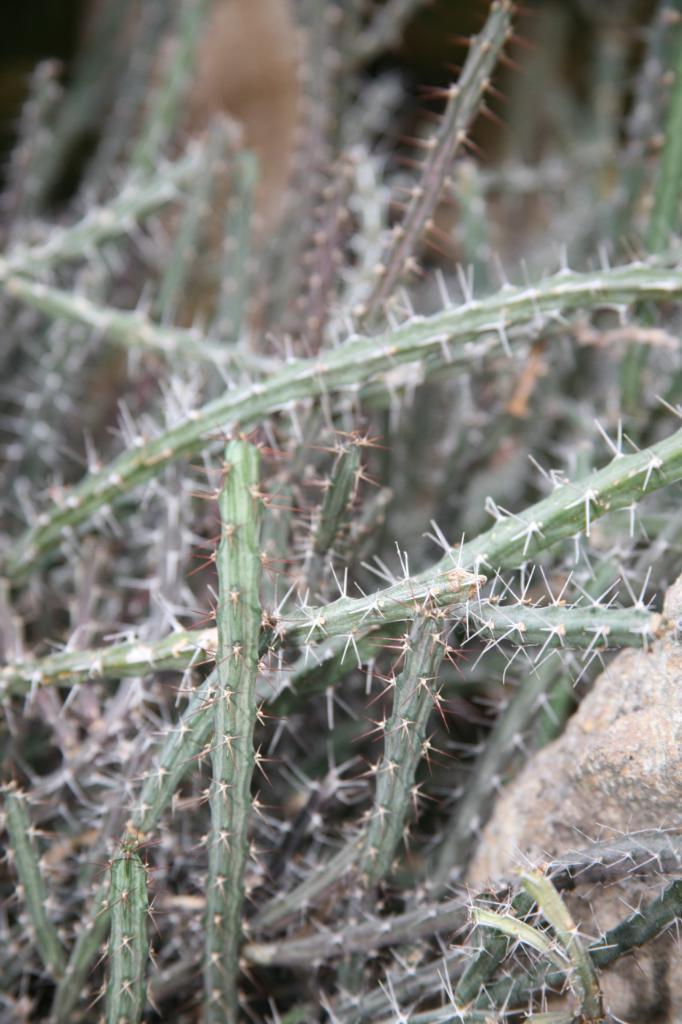How would you summarize this image in a sentence or two? In the image there are cactus plants with thorns. On the right side of the image there is a stone behind the plant. 